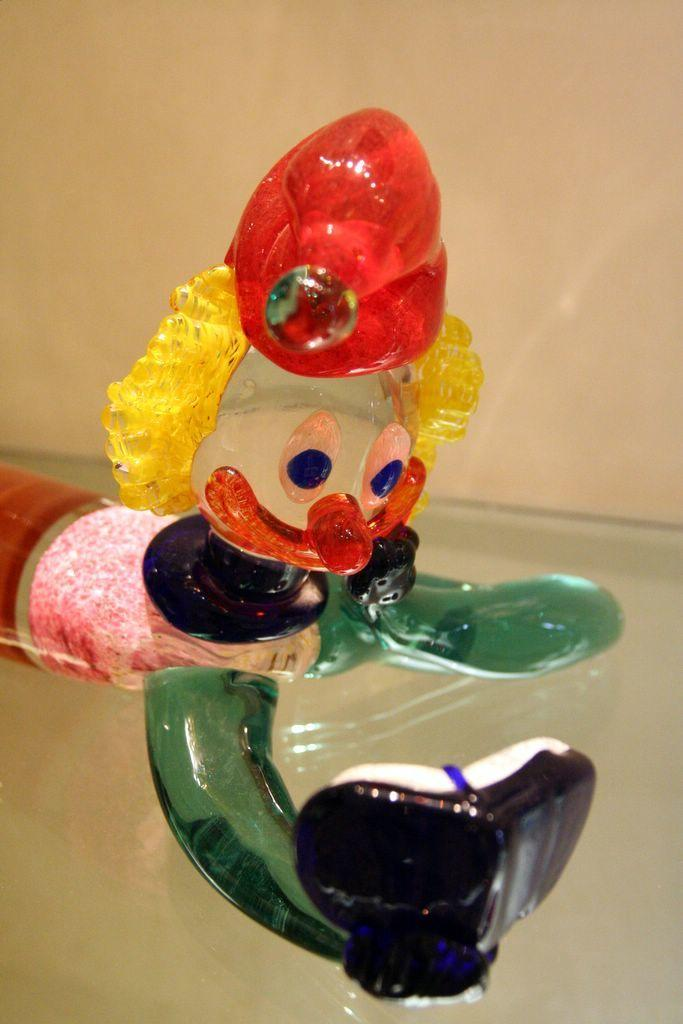What object is placed on the glass table in the image? There is a toy on a glass table in the image. What can be seen in the background of the image? There is a wall in the background of the image. How many boys are sleeping on the farm in the image? There are no boys or farms present in the image; it features a toy on a glass table and a wall in the background. 